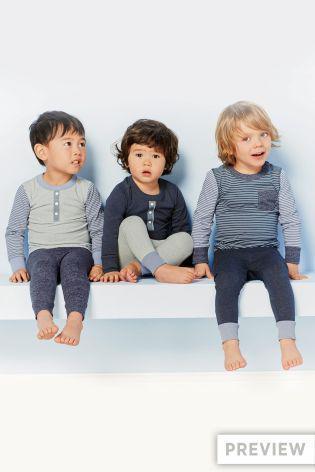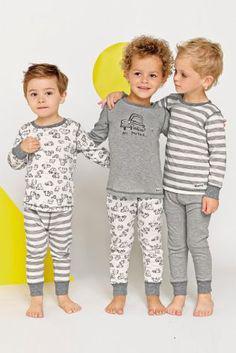The first image is the image on the left, the second image is the image on the right. Evaluate the accuracy of this statement regarding the images: "the left image has the middle child sitting criss cross". Is it true? Answer yes or no. Yes. 